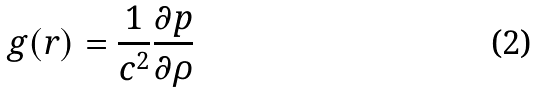<formula> <loc_0><loc_0><loc_500><loc_500>g ( r ) = \frac { 1 } { c ^ { 2 } } \frac { \partial p } { \partial \rho }</formula> 